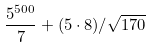Convert formula to latex. <formula><loc_0><loc_0><loc_500><loc_500>\frac { 5 ^ { 5 0 0 } } { 7 } + ( 5 \cdot 8 ) / \sqrt { 1 7 0 }</formula> 